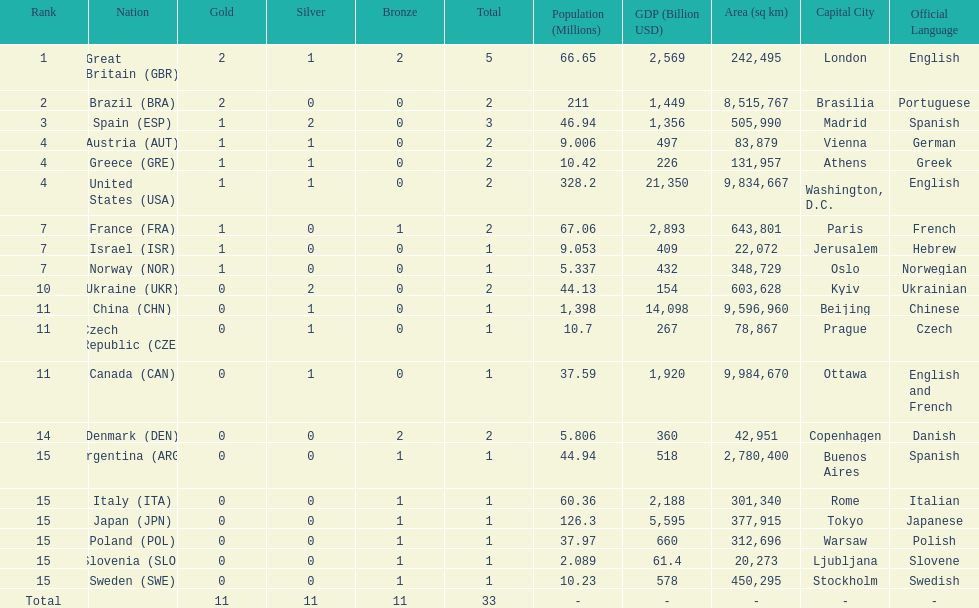Which country won the most medals total? Great Britain (GBR). 